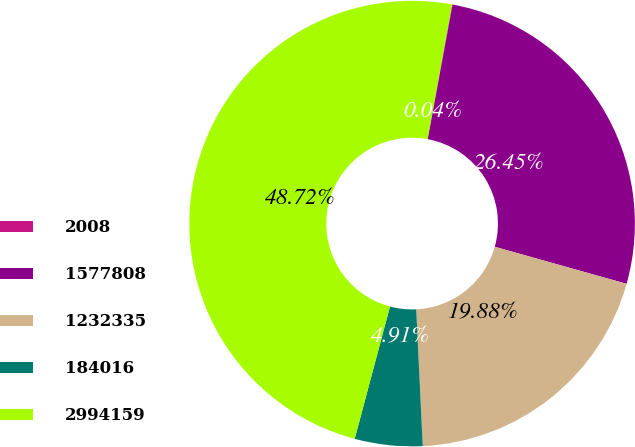Convert chart to OTSL. <chart><loc_0><loc_0><loc_500><loc_500><pie_chart><fcel>2008<fcel>1577808<fcel>1232335<fcel>184016<fcel>2994159<nl><fcel>0.04%<fcel>26.45%<fcel>19.88%<fcel>4.91%<fcel>48.72%<nl></chart> 